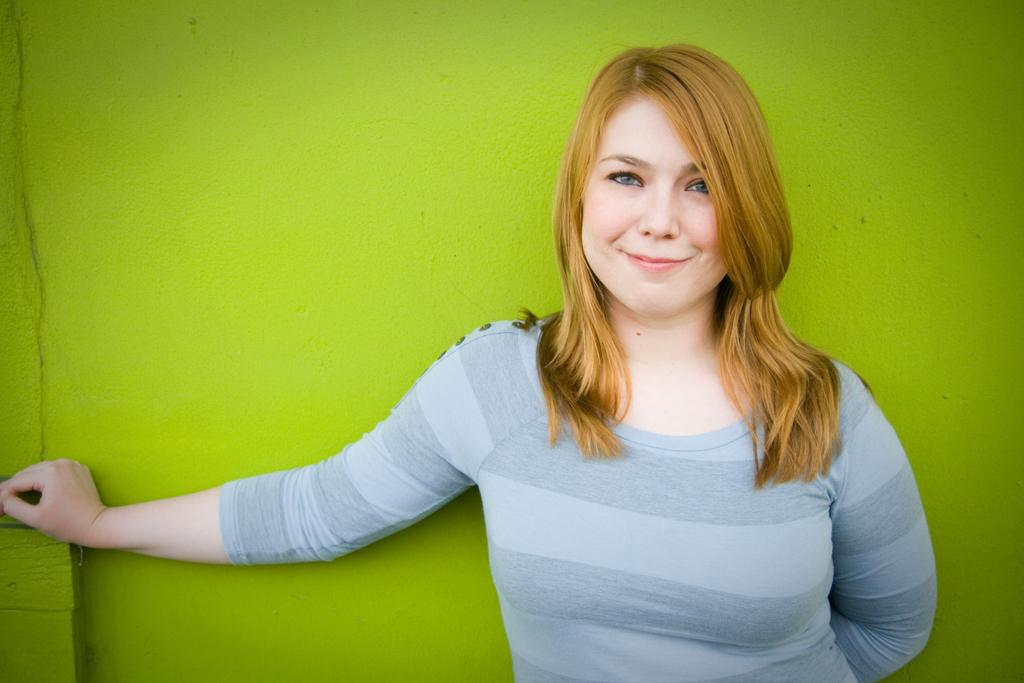Who is the main subject in the image? There is a woman in the image. What is the woman wearing? The woman is wearing a t-shirt. Where is the woman located in the image? The woman is on the left side of the image. What is the woman's facial expression? The woman is smiling. What color is the wall behind the woman? There is a green color wall in the image. What is the title of the idea the woman is presenting in the image? There is no indication in the image that the woman is presenting an idea or that there is a title associated with it. 